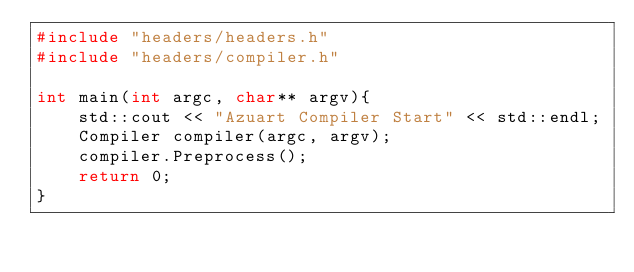<code> <loc_0><loc_0><loc_500><loc_500><_C++_>#include "headers/headers.h"
#include "headers/compiler.h"

int main(int argc, char** argv){
    std::cout << "Azuart Compiler Start" << std::endl;
    Compiler compiler(argc, argv);
    compiler.Preprocess();
    return 0;
}</code> 